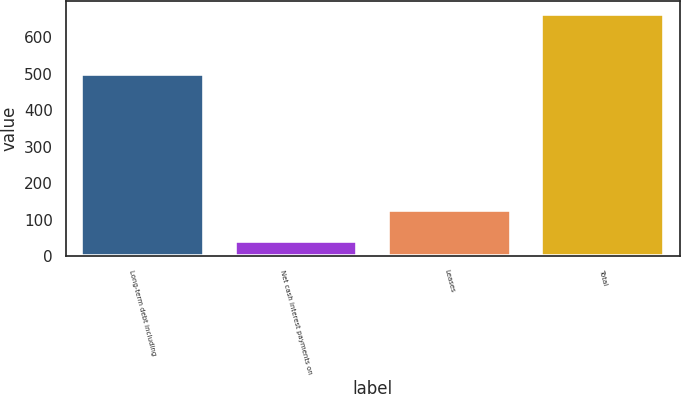Convert chart. <chart><loc_0><loc_0><loc_500><loc_500><bar_chart><fcel>Long-term debt including<fcel>Net cash interest payments on<fcel>Leases<fcel>Total<nl><fcel>498<fcel>41<fcel>126<fcel>665<nl></chart> 